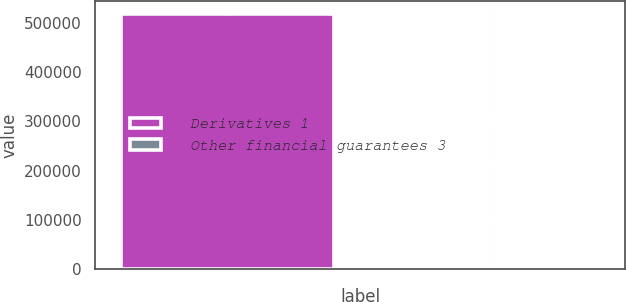Convert chart. <chart><loc_0><loc_0><loc_500><loc_500><bar_chart><fcel>Derivatives 1<fcel>Other financial guarantees 3<nl><fcel>517634<fcel>1361<nl></chart> 